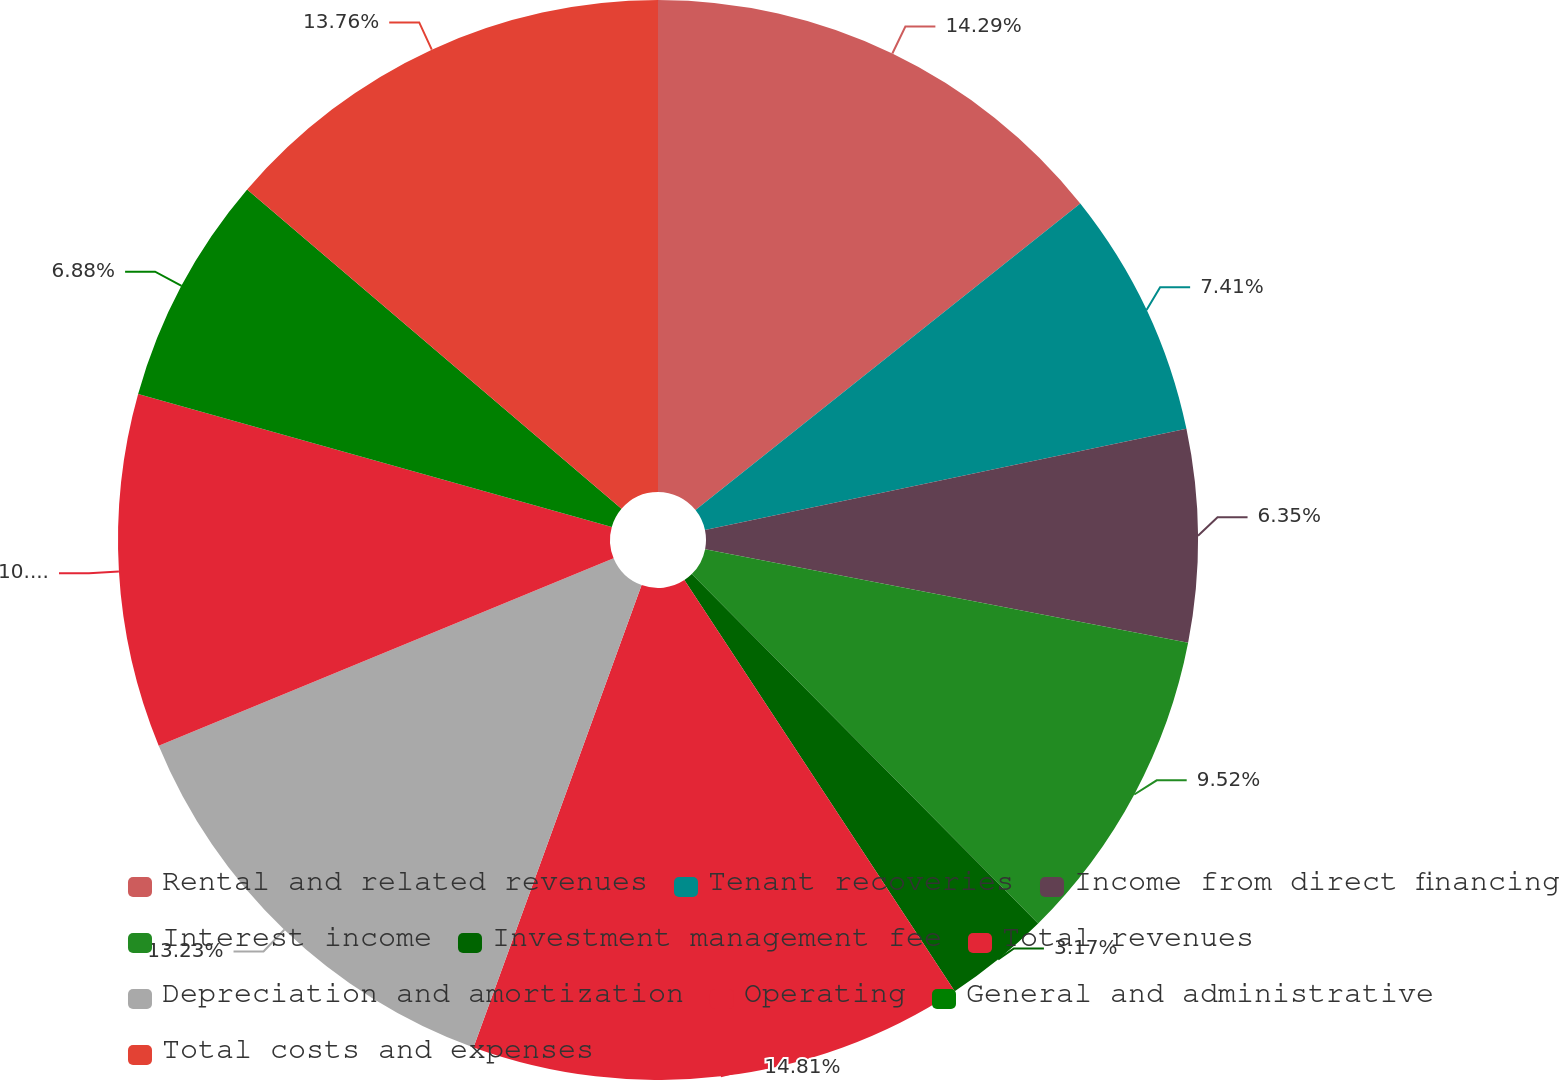<chart> <loc_0><loc_0><loc_500><loc_500><pie_chart><fcel>Rental and related revenues<fcel>Tenant recoveries<fcel>Income from direct financing<fcel>Interest income<fcel>Investment management fee<fcel>Total revenues<fcel>Depreciation and amortization<fcel>Operating<fcel>General and administrative<fcel>Total costs and expenses<nl><fcel>14.29%<fcel>7.41%<fcel>6.35%<fcel>9.52%<fcel>3.17%<fcel>14.81%<fcel>13.23%<fcel>10.58%<fcel>6.88%<fcel>13.76%<nl></chart> 